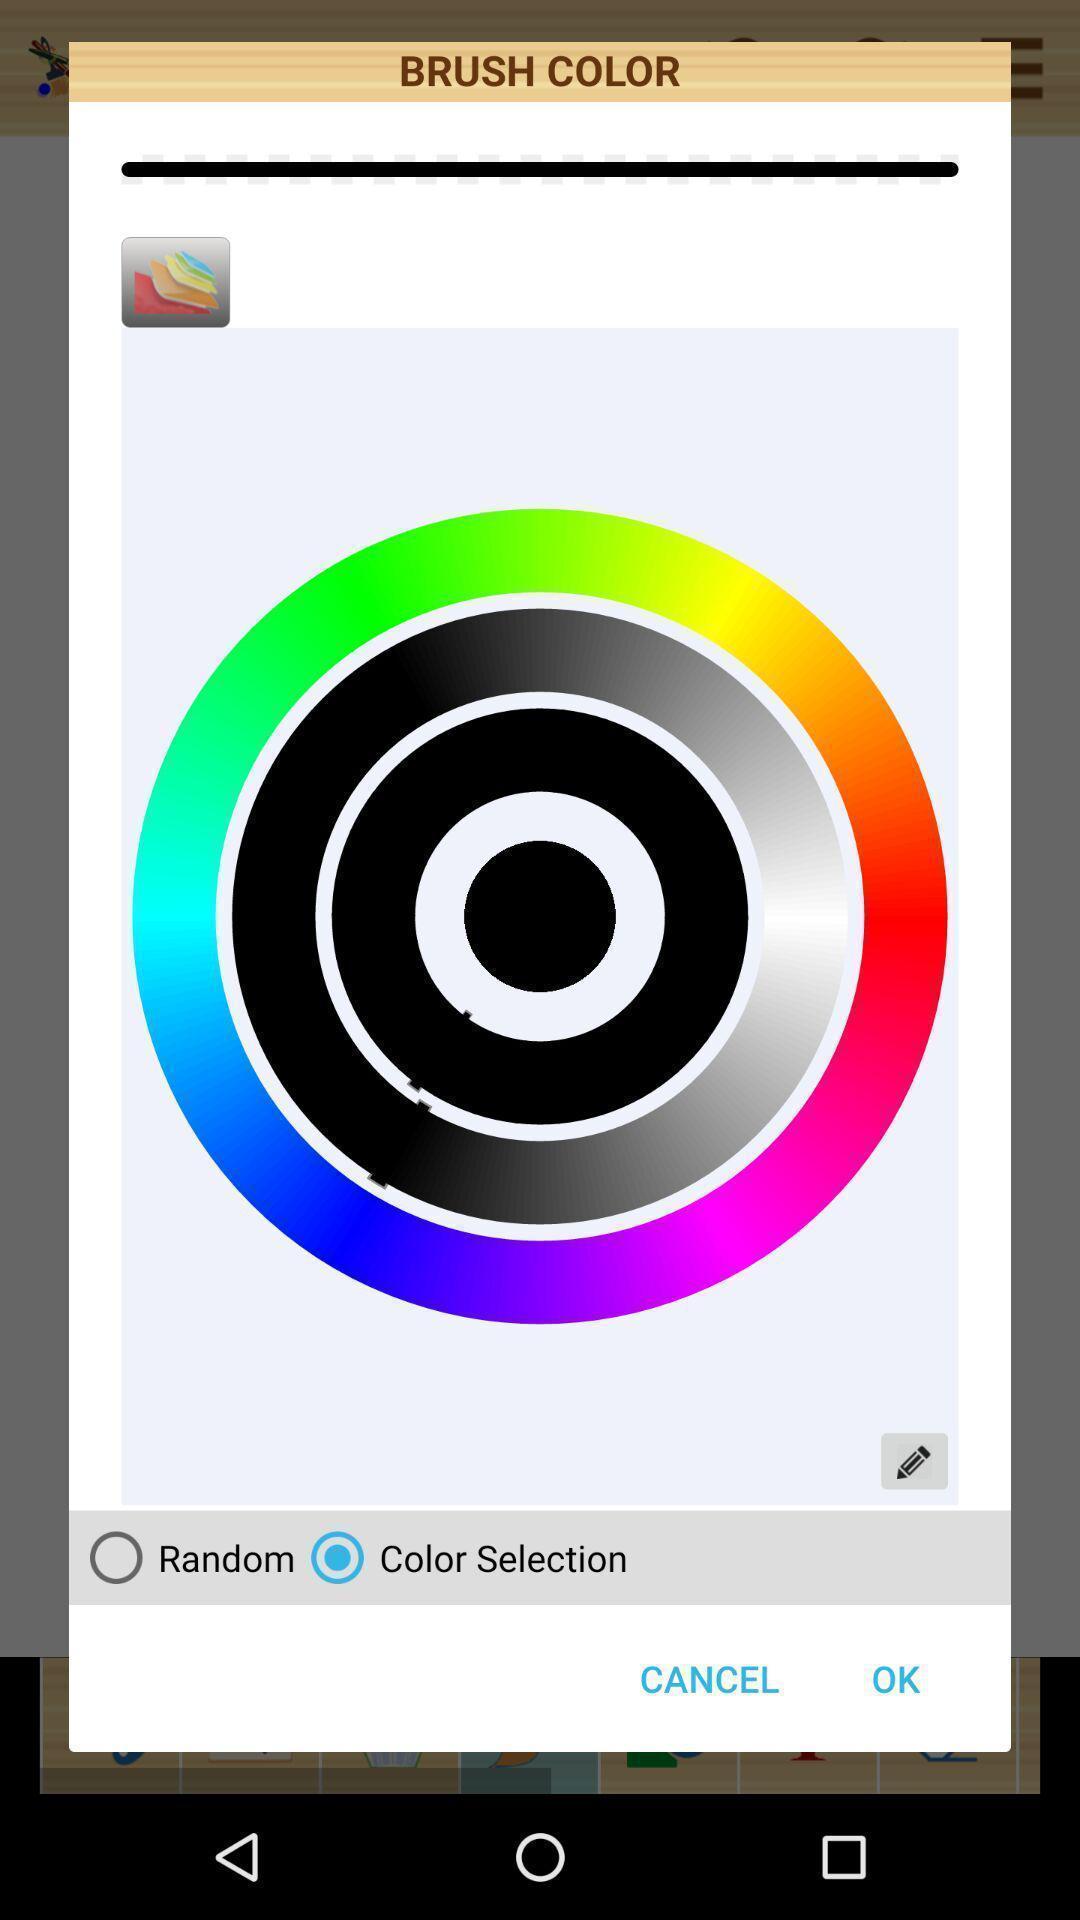Summarize the information in this screenshot. Screen asking to set a brush color. 